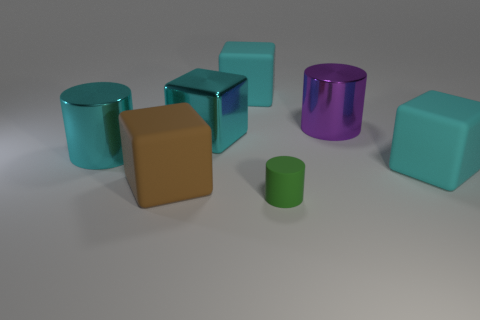Subtract all blue cylinders. How many cyan cubes are left? 3 Subtract 2 blocks. How many blocks are left? 2 Subtract all large metal cubes. How many cubes are left? 3 Subtract all blue blocks. Subtract all green spheres. How many blocks are left? 4 Add 2 large shiny cubes. How many objects exist? 9 Subtract all cubes. How many objects are left? 3 Add 1 cyan metallic things. How many cyan metallic things exist? 3 Subtract 0 gray cylinders. How many objects are left? 7 Subtract all big brown balls. Subtract all large cyan cylinders. How many objects are left? 6 Add 4 big purple metal cylinders. How many big purple metal cylinders are left? 5 